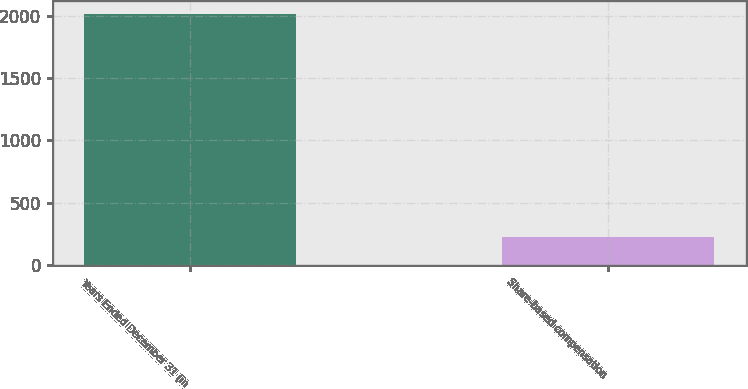Convert chart. <chart><loc_0><loc_0><loc_500><loc_500><bar_chart><fcel>Years Ended December 31 (in<fcel>Share-based compensation<nl><fcel>2014<fcel>227<nl></chart> 